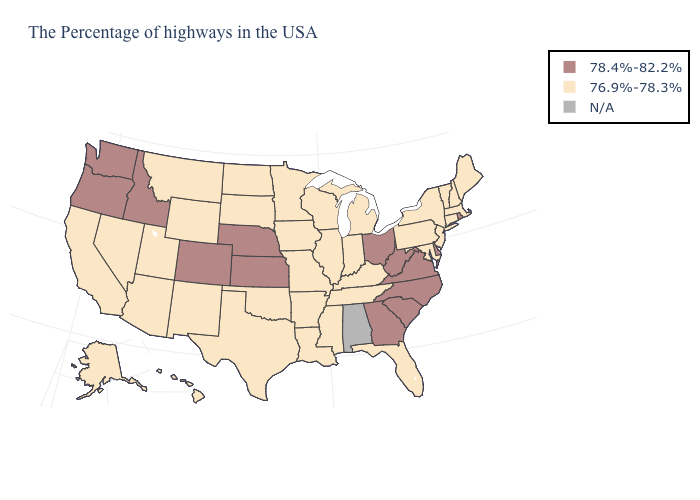How many symbols are there in the legend?
Be succinct. 3. What is the value of Tennessee?
Keep it brief. 76.9%-78.3%. Is the legend a continuous bar?
Write a very short answer. No. Does Michigan have the highest value in the MidWest?
Keep it brief. No. Among the states that border Oklahoma , does Colorado have the lowest value?
Be succinct. No. Does Louisiana have the lowest value in the South?
Be succinct. Yes. Does the first symbol in the legend represent the smallest category?
Quick response, please. No. Does New York have the highest value in the Northeast?
Give a very brief answer. No. What is the value of New Mexico?
Write a very short answer. 76.9%-78.3%. What is the value of Rhode Island?
Answer briefly. 78.4%-82.2%. Does the map have missing data?
Give a very brief answer. Yes. Name the states that have a value in the range N/A?
Answer briefly. Alabama. Name the states that have a value in the range N/A?
Answer briefly. Alabama. Which states hav the highest value in the West?
Keep it brief. Colorado, Idaho, Washington, Oregon. Is the legend a continuous bar?
Quick response, please. No. 